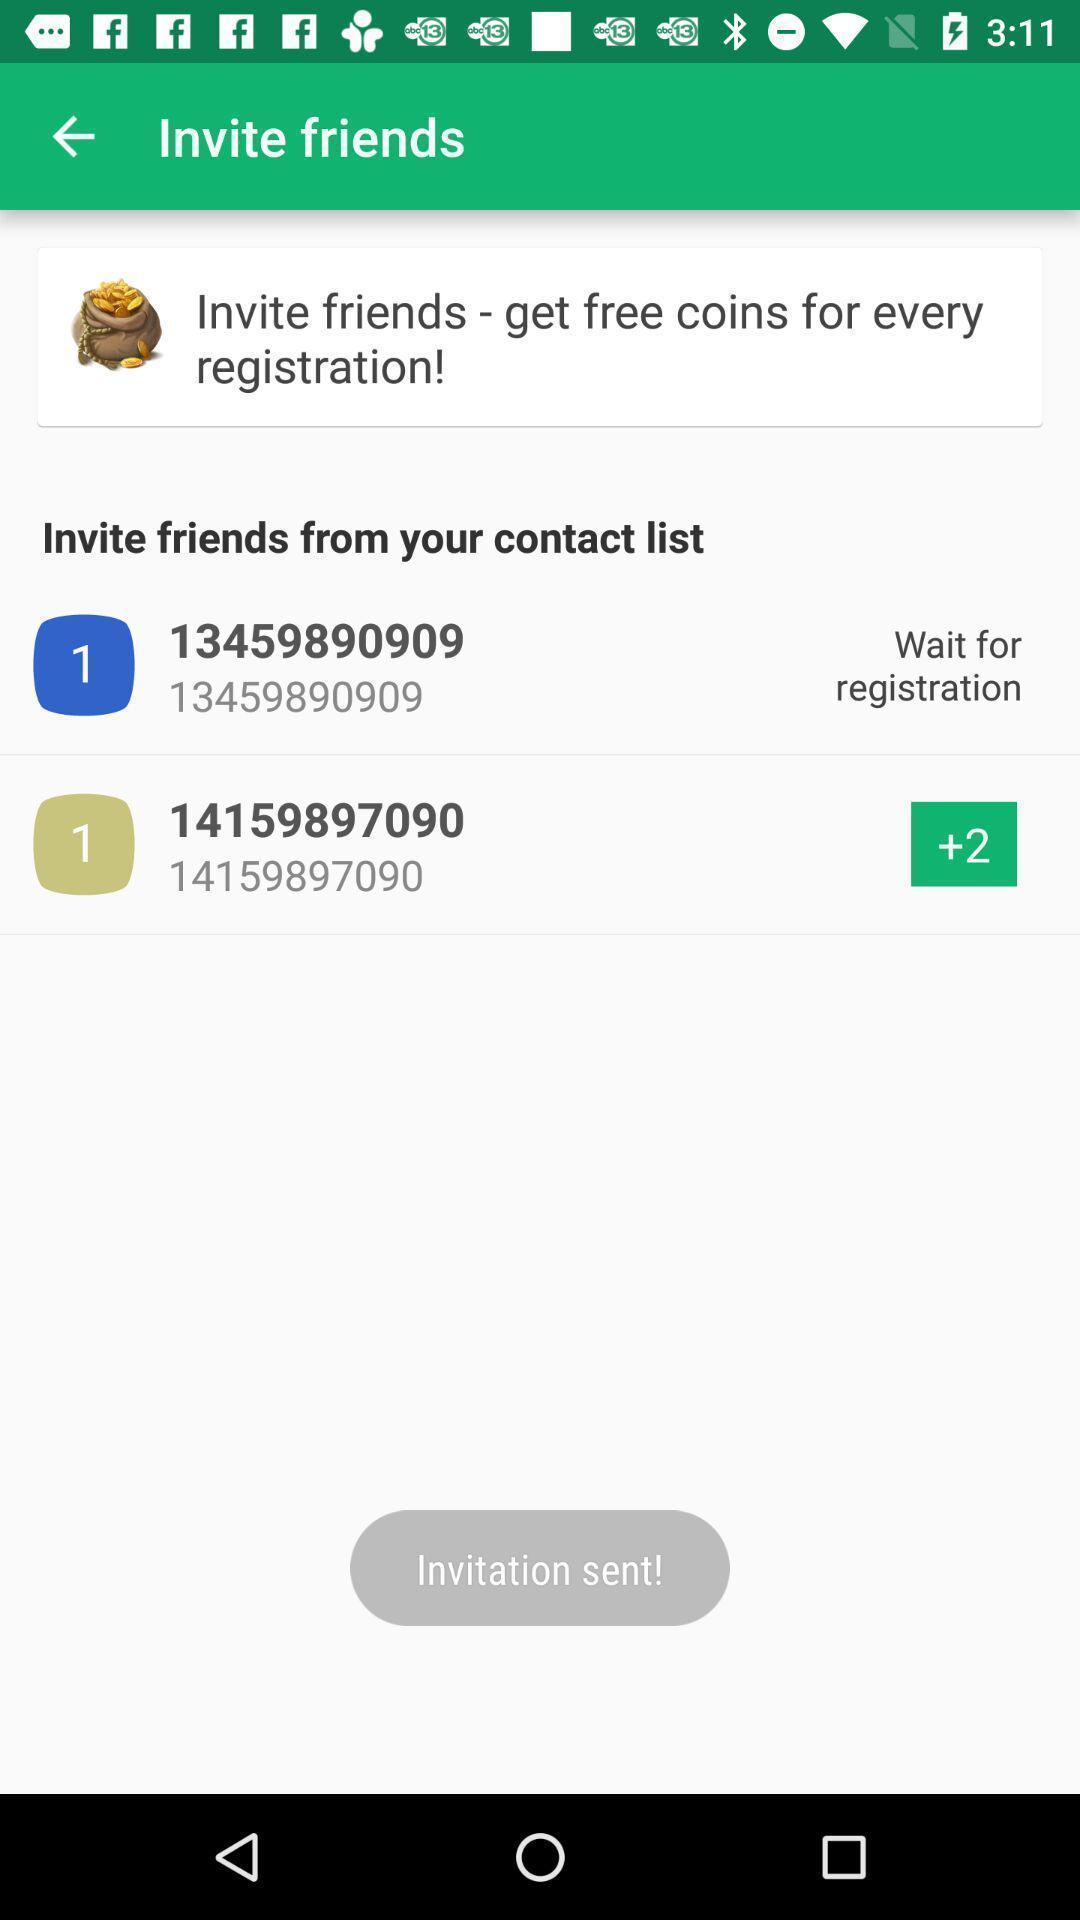Explain the elements present in this screenshot. Screen shows to invite friends. 